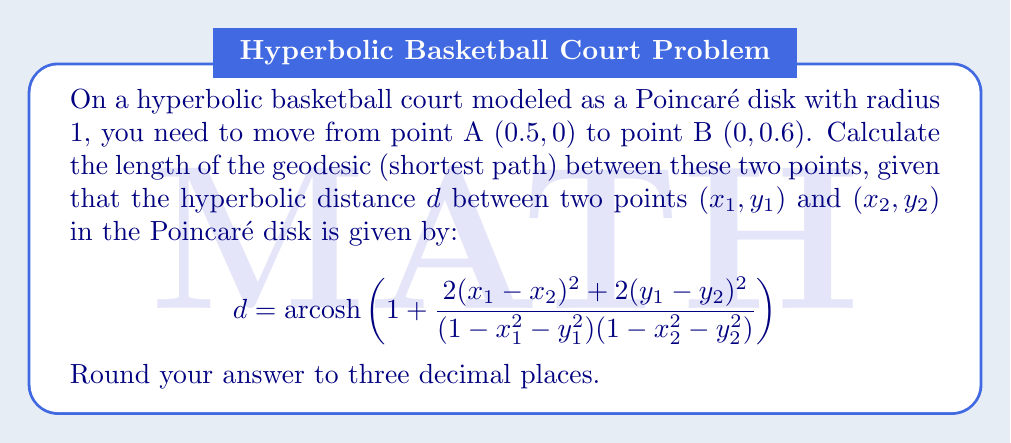Show me your answer to this math problem. To solve this problem, we'll follow these steps:

1) Identify the coordinates of points A and B:
   A: $(x_1, y_1) = (0.5, 0)$
   B: $(x_2, y_2) = (0, 0.6)$

2) Substitute these values into the hyperbolic distance formula:

   $$d = \text{arcosh}\left(1 + \frac{2(0.5 - 0)^2 + 2(0 - 0.6)^2}{(1 - 0.5^2 - 0^2)(1 - 0^2 - 0.6^2)}\right)$$

3) Simplify the numerator:
   $(0.5 - 0)^2 = 0.25$
   $(0 - 0.6)^2 = 0.36$
   $2(0.25) + 2(0.36) = 0.5 + 0.72 = 1.22$

4) Simplify the denominator:
   $(1 - 0.5^2 - 0^2) = 1 - 0.25 = 0.75$
   $(1 - 0^2 - 0.6^2) = 1 - 0.36 = 0.64$
   $0.75 * 0.64 = 0.48$

5) Combine these results:

   $$d = \text{arcosh}\left(1 + \frac{1.22}{0.48}\right)$$

6) Simplify:

   $$d = \text{arcosh}\left(1 + 2.5416666...\right) = \text{arcosh}(3.5416666...)$$

7) Calculate the arccosh value and round to three decimal places:

   $$d \approx 1.920$$
Answer: 1.920 